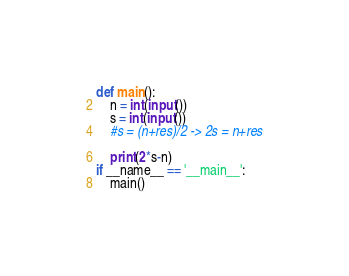Convert code to text. <code><loc_0><loc_0><loc_500><loc_500><_Python_>def main():
    n = int(input())
    s = int(input())
    #s = (n+res)/2 -> 2s = n+res

    print(2*s-n) 
if __name__ == '__main__':
    main()
</code> 